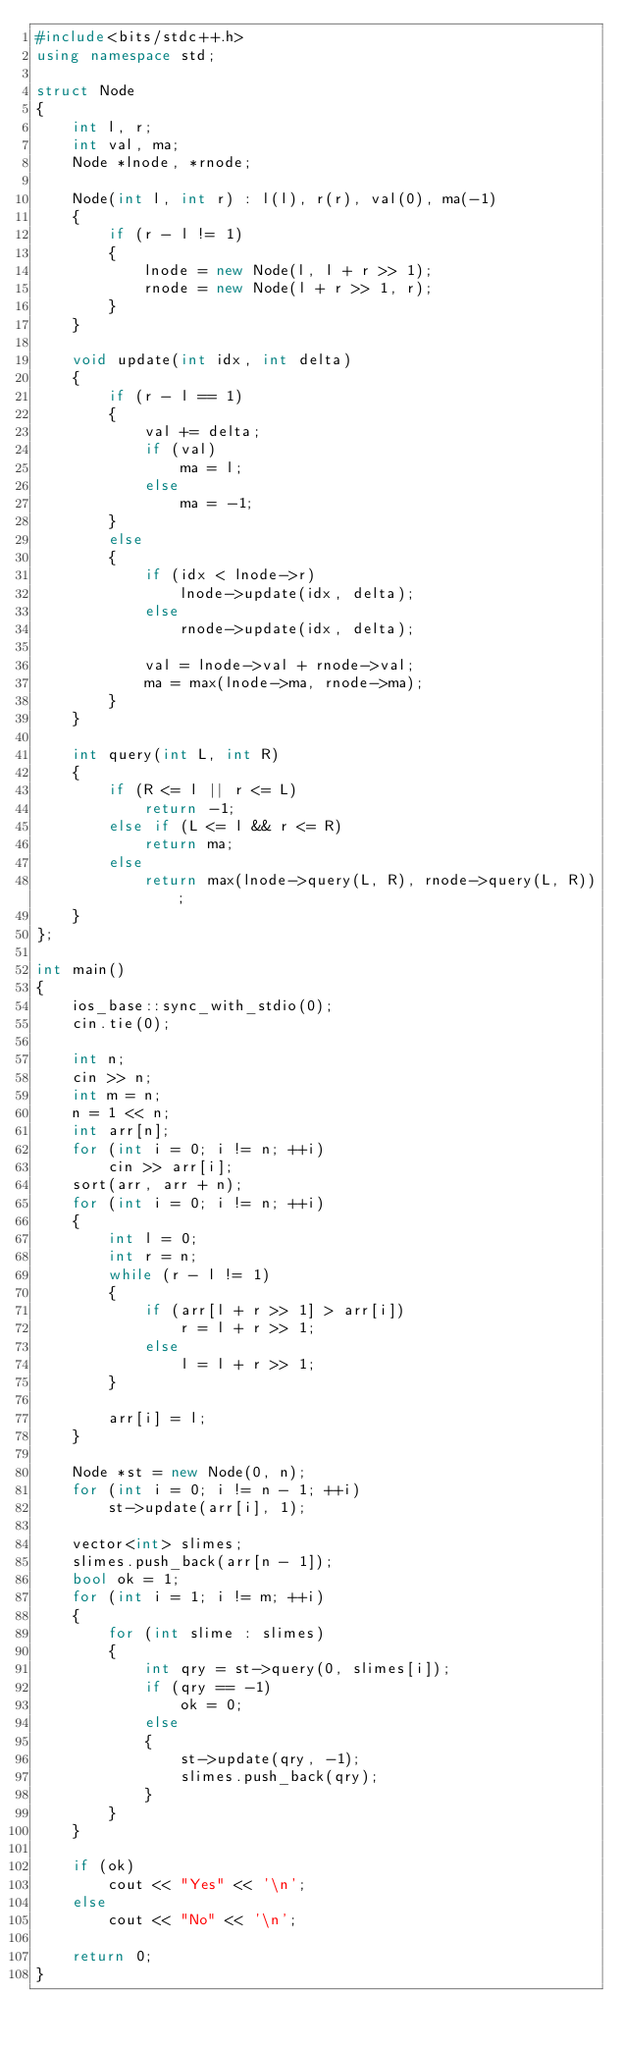Convert code to text. <code><loc_0><loc_0><loc_500><loc_500><_C++_>#include<bits/stdc++.h>
using namespace std;

struct Node
{
    int l, r;
    int val, ma;
    Node *lnode, *rnode;
    
    Node(int l, int r) : l(l), r(r), val(0), ma(-1)
    {
        if (r - l != 1)
        {
            lnode = new Node(l, l + r >> 1);
            rnode = new Node(l + r >> 1, r);
        }
    }
    
    void update(int idx, int delta)
    {
        if (r - l == 1)
        {
            val += delta;
            if (val)
                ma = l;
            else
                ma = -1;
        }
        else
        {
            if (idx < lnode->r)
                lnode->update(idx, delta);
            else
                rnode->update(idx, delta);
            
            val = lnode->val + rnode->val;
            ma = max(lnode->ma, rnode->ma);
        }
    }
    
    int query(int L, int R)
    {
        if (R <= l || r <= L)
            return -1;
        else if (L <= l && r <= R)
            return ma;
        else
            return max(lnode->query(L, R), rnode->query(L, R));
    }
};

int main()
{
    ios_base::sync_with_stdio(0);
    cin.tie(0);
    
    int n;
    cin >> n;
    int m = n;
    n = 1 << n;
    int arr[n];
    for (int i = 0; i != n; ++i)
        cin >> arr[i];
    sort(arr, arr + n);
    for (int i = 0; i != n; ++i)
    {
        int l = 0;
        int r = n;
        while (r - l != 1)
        {
            if (arr[l + r >> 1] > arr[i])
                r = l + r >> 1;
            else
                l = l + r >> 1;
        }
        
        arr[i] = l;
    }
    
    Node *st = new Node(0, n);
    for (int i = 0; i != n - 1; ++i)
        st->update(arr[i], 1);
    
    vector<int> slimes;
    slimes.push_back(arr[n - 1]);
    bool ok = 1;
    for (int i = 1; i != m; ++i)
    {
        for (int slime : slimes)
        {
            int qry = st->query(0, slimes[i]);
            if (qry == -1)
                ok = 0;
            else
            {
                st->update(qry, -1);
                slimes.push_back(qry);
            }
        }
    }
    
    if (ok)
        cout << "Yes" << '\n';
    else
        cout << "No" << '\n';
    
    return 0;
}
</code> 